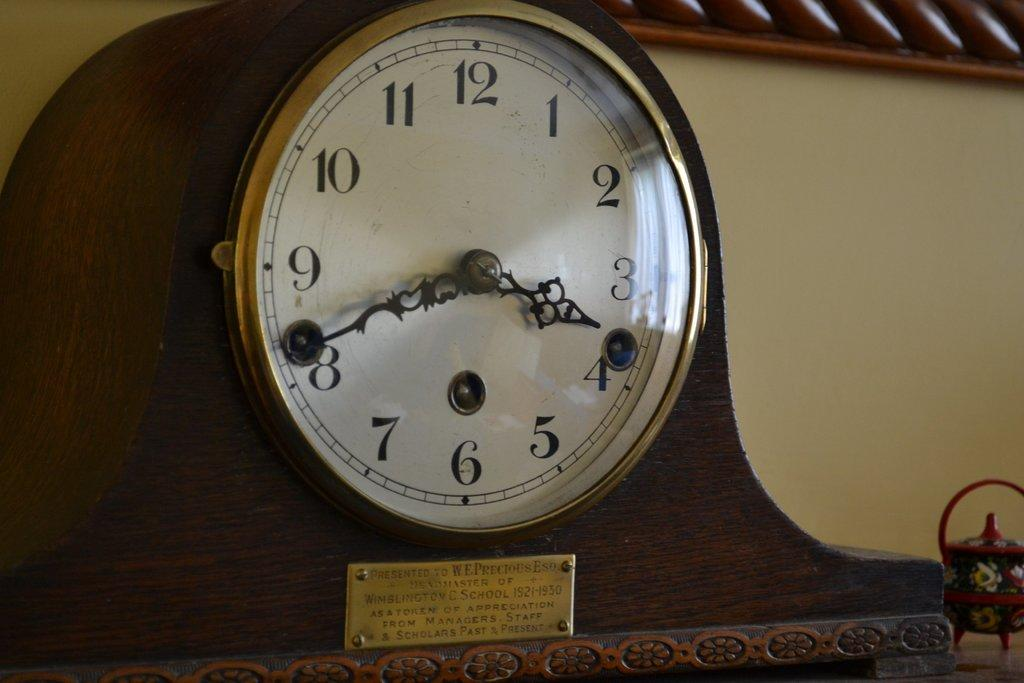<image>
Share a concise interpretation of the image provided. A mantle clock has a plaque that has the dates 1921-1930 on it. 